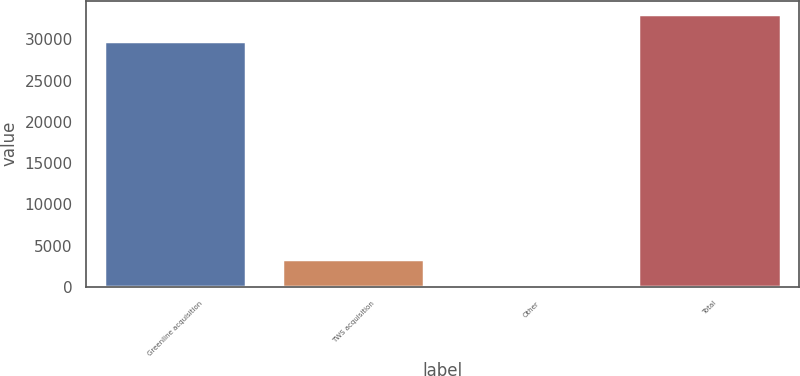Convert chart to OTSL. <chart><loc_0><loc_0><loc_500><loc_500><bar_chart><fcel>Greenline acquisition<fcel>TWS acquisition<fcel>Other<fcel>Total<nl><fcel>29853<fcel>3405<fcel>202<fcel>33056<nl></chart> 